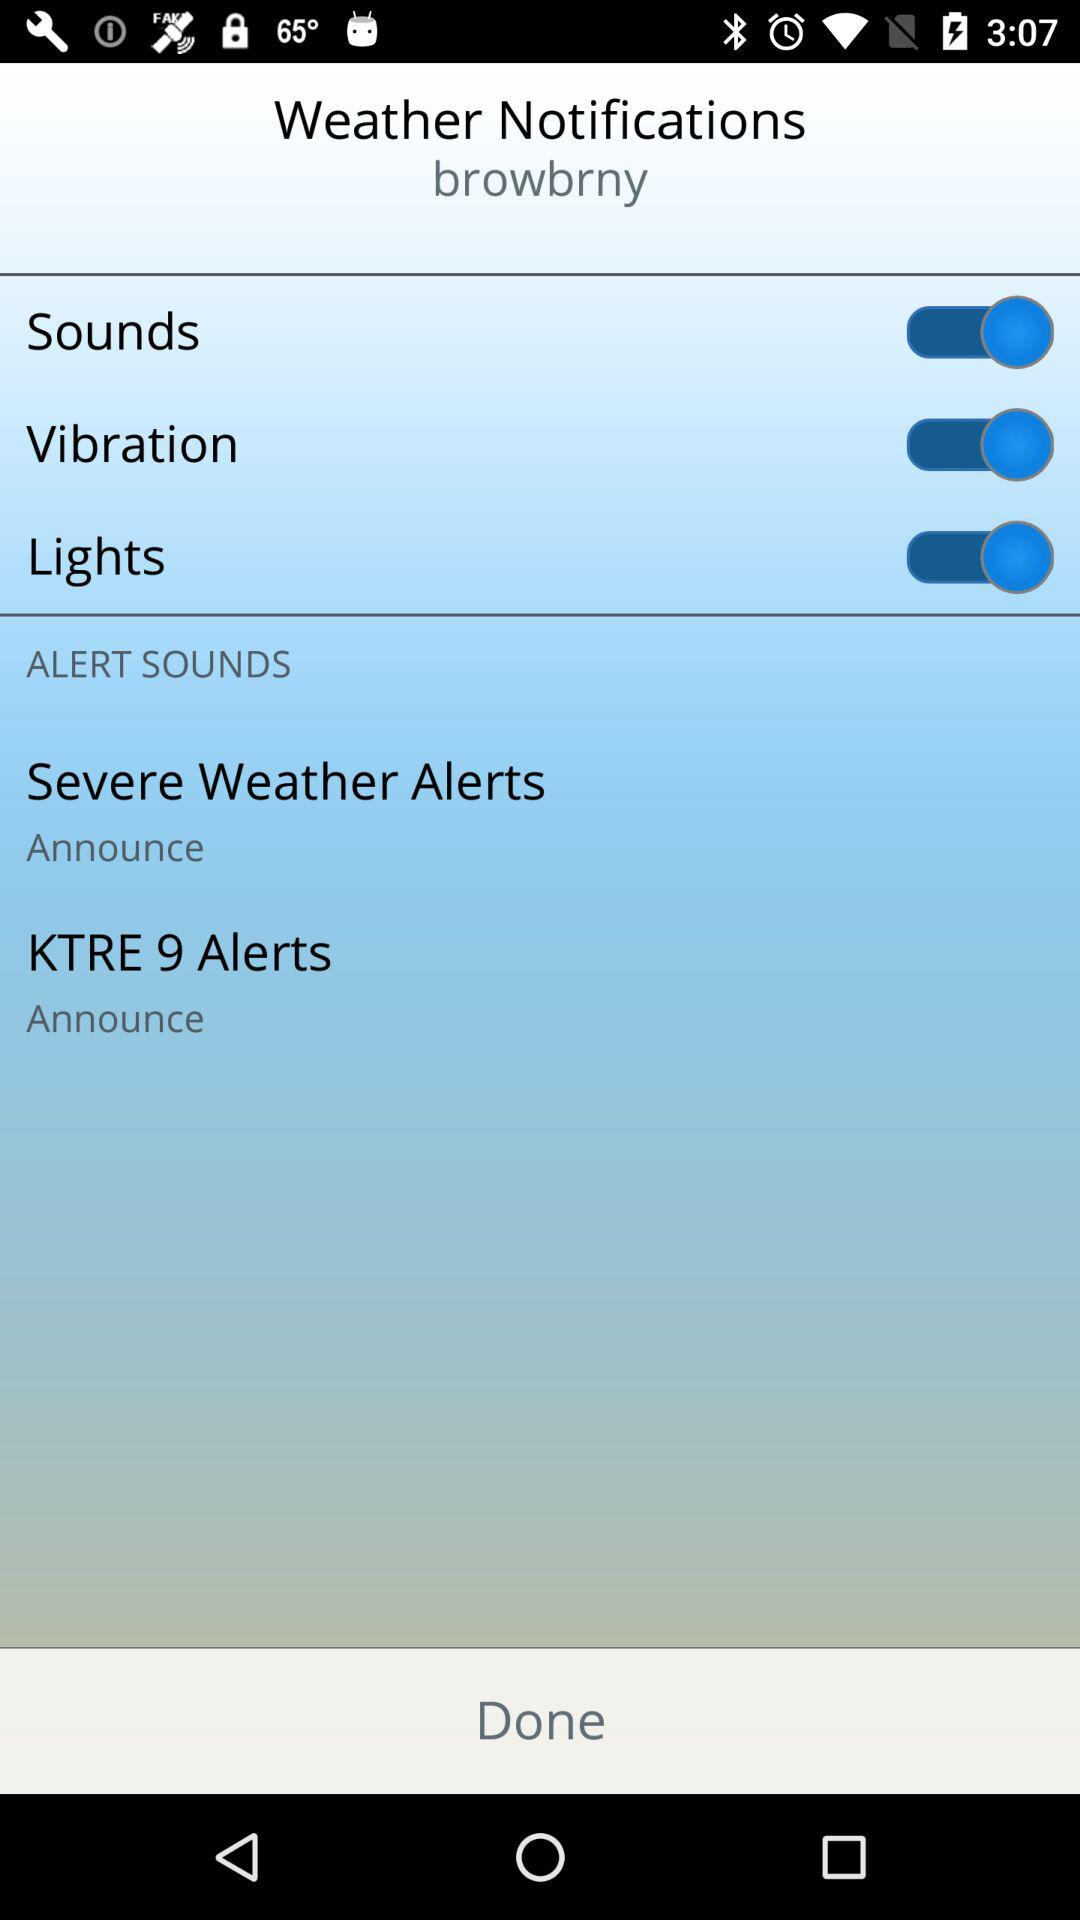How many alert sounds are there?
Answer the question using a single word or phrase. 2 